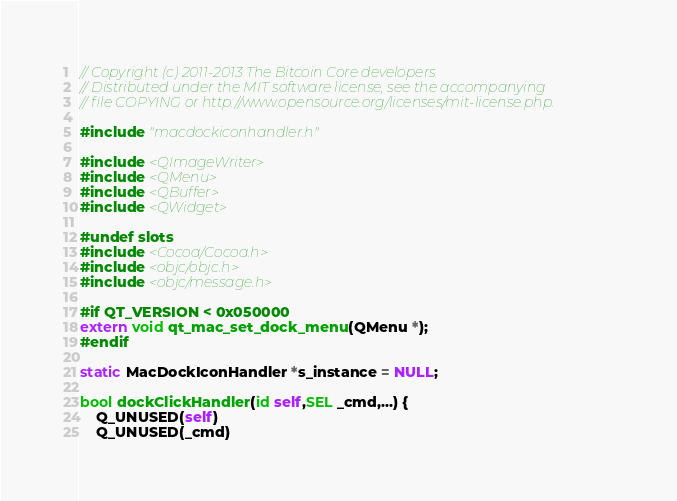Convert code to text. <code><loc_0><loc_0><loc_500><loc_500><_ObjectiveC_>// Copyright (c) 2011-2013 The Bitcoin Core developers
// Distributed under the MIT software license, see the accompanying
// file COPYING or http://www.opensource.org/licenses/mit-license.php.

#include "macdockiconhandler.h"

#include <QImageWriter>
#include <QMenu>
#include <QBuffer>
#include <QWidget>

#undef slots
#include <Cocoa/Cocoa.h>
#include <objc/objc.h>
#include <objc/message.h>

#if QT_VERSION < 0x050000
extern void qt_mac_set_dock_menu(QMenu *);
#endif

static MacDockIconHandler *s_instance = NULL;

bool dockClickHandler(id self,SEL _cmd,...) {
    Q_UNUSED(self)
    Q_UNUSED(_cmd)
</code> 